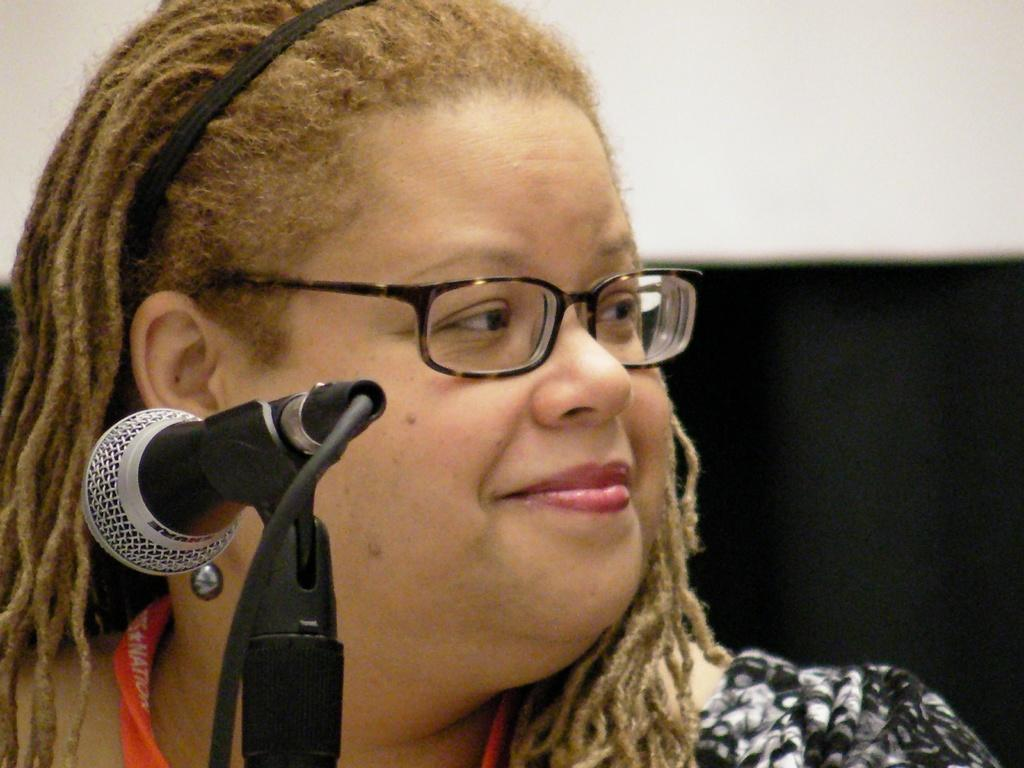Who is present in the image? There is a woman in the image. What is the woman wearing? The woman is wearing a black dress. What expression does the woman have? The woman is smiling. What object can be seen in the image that is typically used for amplifying sound? There is a microphone in the image, and it is attached to a stand. What colors can be seen in the background of the image? There is a black sheet and a white wall in the background of the image. Where is the dock located in the image? There is no dock present in the image. What type of dolls can be seen playing with the wing in the image? There are no dolls or wings present in the image. 